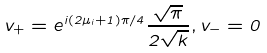<formula> <loc_0><loc_0><loc_500><loc_500>v _ { + } = e ^ { i ( 2 \mu _ { i } + 1 ) \pi / 4 } \frac { \sqrt { \pi } } { 2 \sqrt { k } } , v _ { - } = 0</formula> 